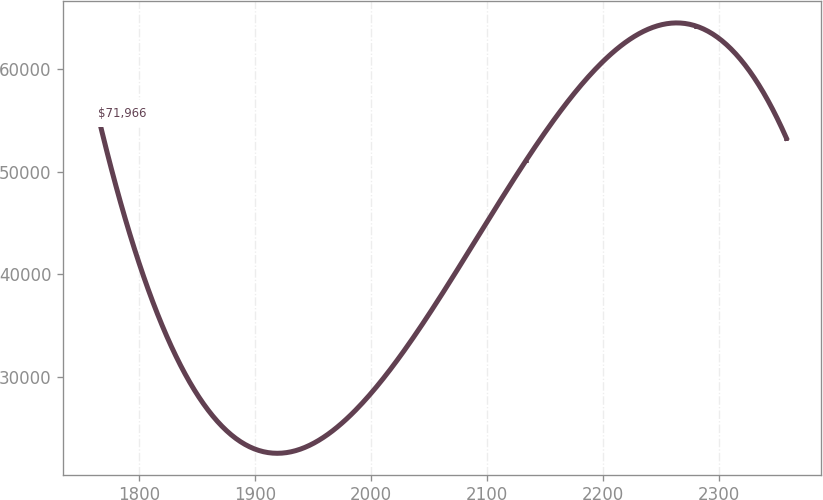Convert chart to OTSL. <chart><loc_0><loc_0><loc_500><loc_500><line_chart><ecel><fcel>$71,966<nl><fcel>1764.33<fcel>55682.1<nl><fcel>2134.11<fcel>51122.4<nl><fcel>2280.54<fcel>64219.1<nl><fcel>2358.55<fcel>53278.3<nl></chart> 